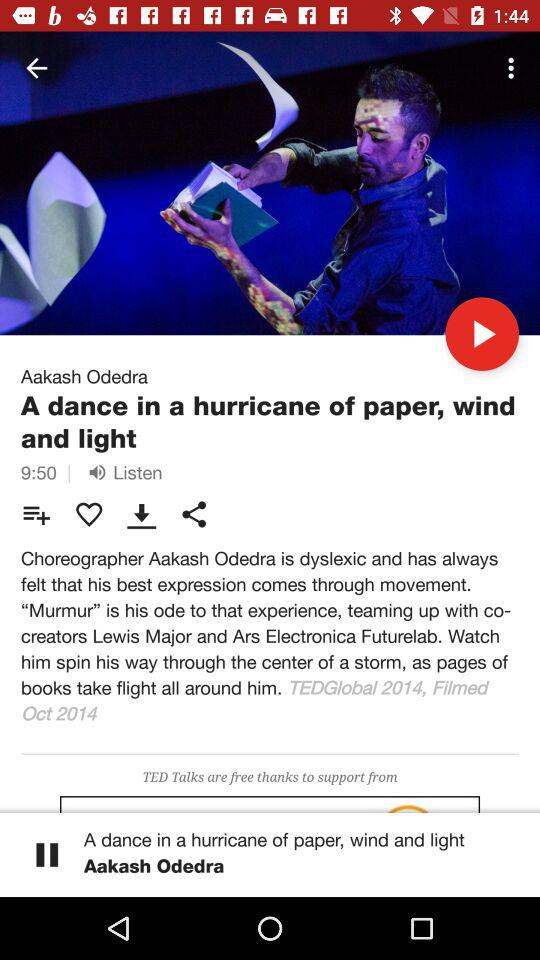What is the filming month and year? The filming month and year are October and 2014, respectively. 